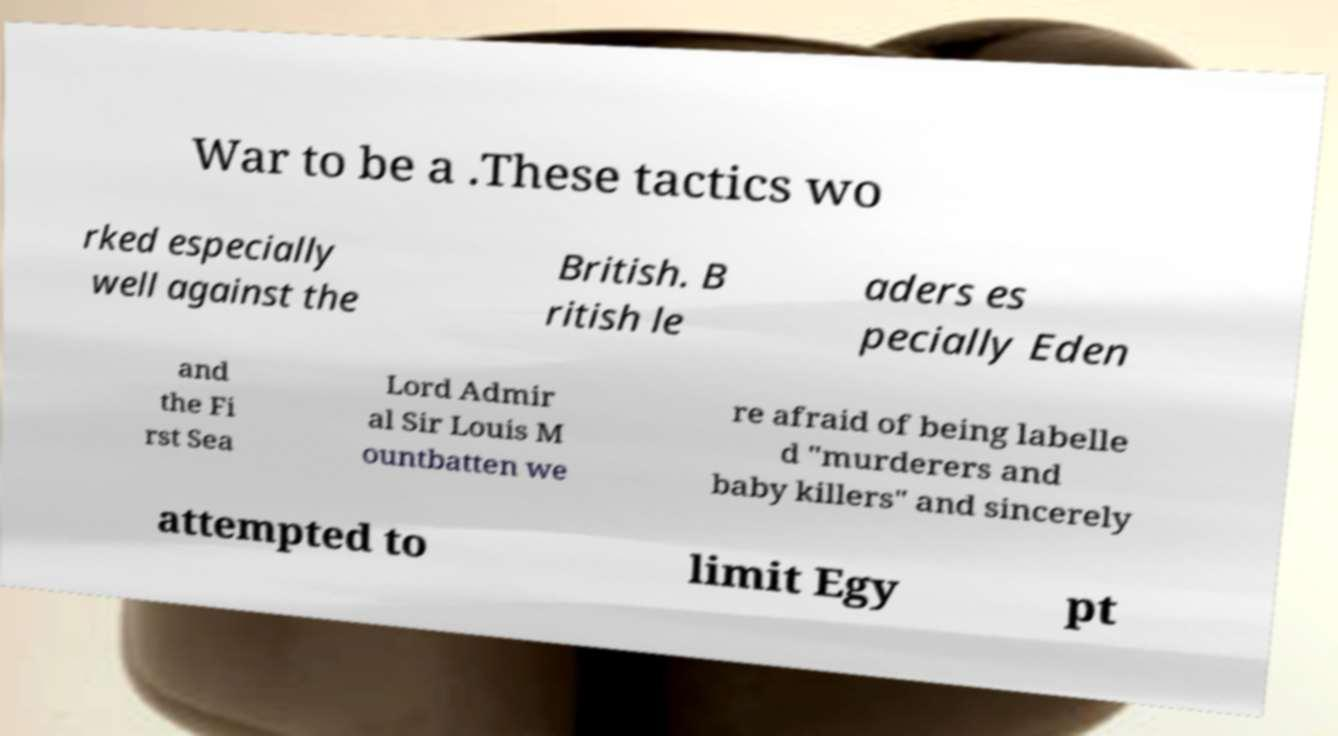What messages or text are displayed in this image? I need them in a readable, typed format. War to be a .These tactics wo rked especially well against the British. B ritish le aders es pecially Eden and the Fi rst Sea Lord Admir al Sir Louis M ountbatten we re afraid of being labelle d "murderers and baby killers" and sincerely attempted to limit Egy pt 